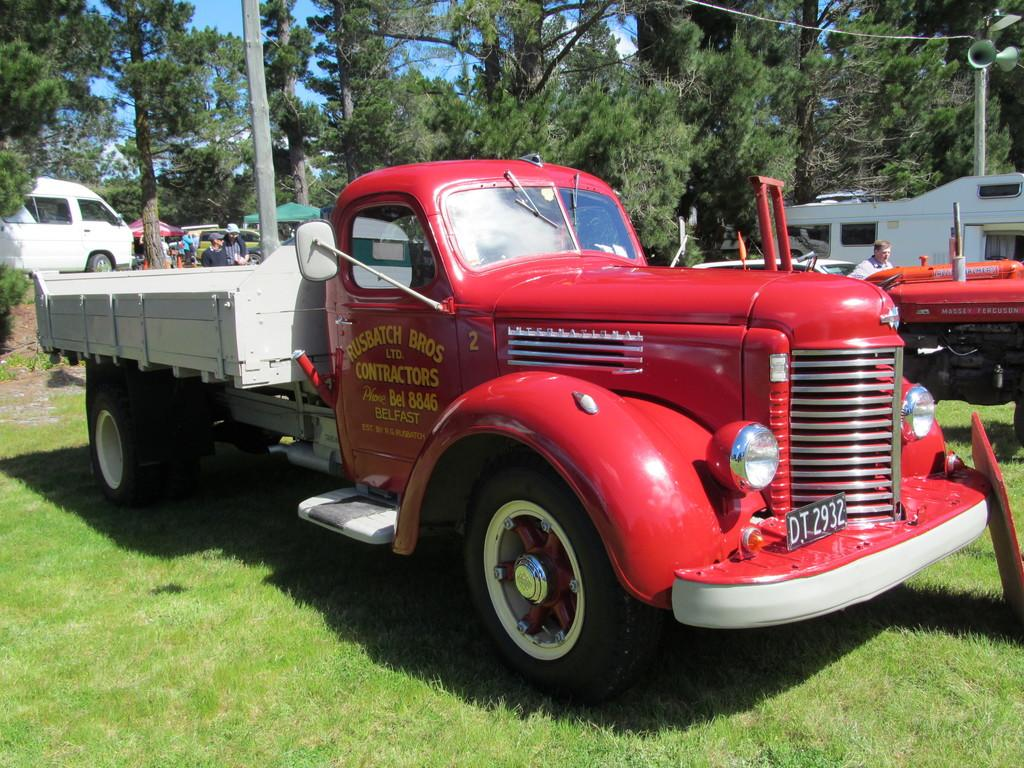What types of objects are present in the image? There are vehicles, a group of people, canopy tents, megaphones on a pole, and trees in the image. Can you describe the people in the image? There is a group of people standing in the image. What might the megaphones on a pole be used for? The megaphones on a pole might be used for amplifying sound or making announcements. What can be seen in the background of the image? The sky is visible in the background of the image. What time of day is it in the image, given the presence of the morning sun? There is no mention of the morning sun or any specific time of day in the image. The sky is visible in the background, but no details about the time of day can be determined from the image. 